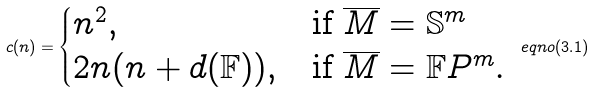<formula> <loc_0><loc_0><loc_500><loc_500>c ( n ) = \begin{cases} n ^ { 2 } , & \text {if $\overline{M}=\mathbb{S}^{m}$} \\ 2 n ( n + d ( \mathbb { F } ) ) , & \text {if $\overline{M}= \mathbb{F}P^{m}.$} \end{cases} \ e q n o { ( 3 . 1 ) }</formula> 